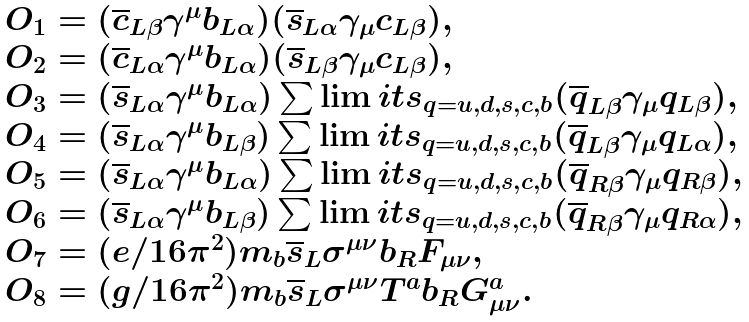Convert formula to latex. <formula><loc_0><loc_0><loc_500><loc_500>\begin{array} { l } O _ { 1 } = ( \overline { c } _ { L \beta } \gamma ^ { \mu } b _ { L \alpha } ) ( \overline { s } _ { L \alpha } \gamma _ { \mu } c _ { L \beta } ) , \\ O _ { 2 } = ( \overline { c } _ { L \alpha } \gamma ^ { \mu } b _ { L \alpha } ) ( \overline { s } _ { L \beta } \gamma _ { \mu } c _ { L \beta } ) , \\ O _ { 3 } = ( \overline { s } _ { L \alpha } \gamma ^ { \mu } b _ { L \alpha } ) \sum \lim i t s _ { q = u , d , s , c , b } ( \overline { q } _ { L \beta } \gamma _ { \mu } q _ { L \beta } ) , \\ O _ { 4 } = ( \overline { s } _ { L \alpha } \gamma ^ { \mu } b _ { L \beta } ) \sum \lim i t s _ { q = u , d , s , c , b } ( \overline { q } _ { L \beta } \gamma _ { \mu } q _ { L \alpha } ) , \\ O _ { 5 } = ( \overline { s } _ { L \alpha } \gamma ^ { \mu } b _ { L \alpha } ) \sum \lim i t s _ { q = u , d , s , c , b } ( \overline { q } _ { R \beta } \gamma _ { \mu } q _ { R \beta } ) , \\ O _ { 6 } = ( \overline { s } _ { L \alpha } \gamma ^ { \mu } b _ { L \beta } ) \sum \lim i t s _ { q = u , d , s , c , b } ( \overline { q } _ { R \beta } \gamma _ { \mu } q _ { R \alpha } ) , \\ O _ { 7 } = ( e / 1 6 \pi ^ { 2 } ) m _ { b } \overline { s } _ { L } \sigma ^ { \mu \nu } b _ { R } F _ { \mu \nu } , \\ O _ { 8 } = ( g / 1 6 \pi ^ { 2 } ) m _ { b } \overline { s } _ { L } \sigma ^ { \mu \nu } T ^ { a } b _ { R } G ^ { a } _ { \mu \nu } . \end{array}</formula> 